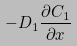<formula> <loc_0><loc_0><loc_500><loc_500>- D _ { 1 } \frac { \partial C _ { 1 } } { \partial x }</formula> 